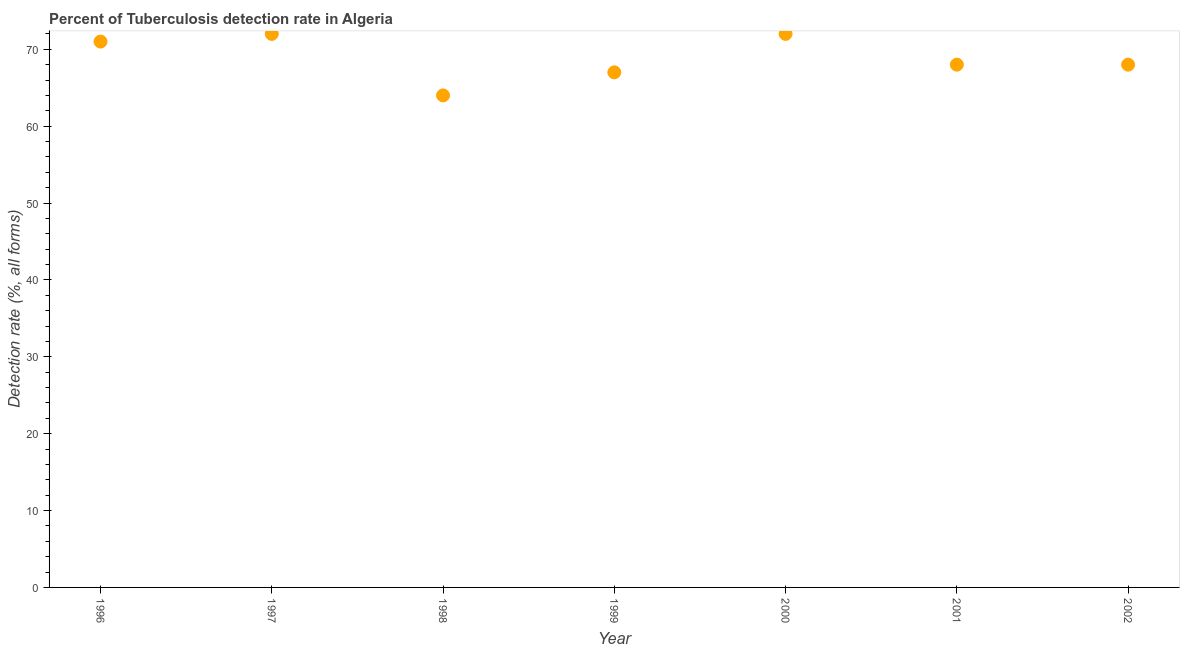What is the detection rate of tuberculosis in 2000?
Your response must be concise. 72. Across all years, what is the maximum detection rate of tuberculosis?
Provide a short and direct response. 72. Across all years, what is the minimum detection rate of tuberculosis?
Ensure brevity in your answer.  64. In which year was the detection rate of tuberculosis maximum?
Your response must be concise. 1997. In which year was the detection rate of tuberculosis minimum?
Provide a succinct answer. 1998. What is the sum of the detection rate of tuberculosis?
Provide a succinct answer. 482. What is the difference between the detection rate of tuberculosis in 1997 and 2001?
Offer a very short reply. 4. What is the average detection rate of tuberculosis per year?
Make the answer very short. 68.86. What is the median detection rate of tuberculosis?
Keep it short and to the point. 68. What is the ratio of the detection rate of tuberculosis in 1996 to that in 1999?
Make the answer very short. 1.06. Is the detection rate of tuberculosis in 1996 less than that in 2002?
Provide a short and direct response. No. Is the difference between the detection rate of tuberculosis in 1996 and 1999 greater than the difference between any two years?
Your answer should be very brief. No. Is the sum of the detection rate of tuberculosis in 1997 and 2001 greater than the maximum detection rate of tuberculosis across all years?
Your answer should be very brief. Yes. What is the difference between the highest and the lowest detection rate of tuberculosis?
Make the answer very short. 8. How many years are there in the graph?
Keep it short and to the point. 7. Are the values on the major ticks of Y-axis written in scientific E-notation?
Make the answer very short. No. Does the graph contain any zero values?
Offer a terse response. No. Does the graph contain grids?
Ensure brevity in your answer.  No. What is the title of the graph?
Provide a succinct answer. Percent of Tuberculosis detection rate in Algeria. What is the label or title of the Y-axis?
Your answer should be very brief. Detection rate (%, all forms). What is the Detection rate (%, all forms) in 1996?
Provide a succinct answer. 71. What is the Detection rate (%, all forms) in 1998?
Provide a short and direct response. 64. What is the Detection rate (%, all forms) in 1999?
Provide a succinct answer. 67. What is the Detection rate (%, all forms) in 2001?
Offer a terse response. 68. What is the Detection rate (%, all forms) in 2002?
Provide a short and direct response. 68. What is the difference between the Detection rate (%, all forms) in 1996 and 1998?
Ensure brevity in your answer.  7. What is the difference between the Detection rate (%, all forms) in 1996 and 1999?
Provide a succinct answer. 4. What is the difference between the Detection rate (%, all forms) in 1996 and 2000?
Make the answer very short. -1. What is the difference between the Detection rate (%, all forms) in 1997 and 2000?
Your response must be concise. 0. What is the difference between the Detection rate (%, all forms) in 1998 and 1999?
Offer a very short reply. -3. What is the difference between the Detection rate (%, all forms) in 1999 and 2000?
Ensure brevity in your answer.  -5. What is the difference between the Detection rate (%, all forms) in 2000 and 2001?
Offer a very short reply. 4. What is the difference between the Detection rate (%, all forms) in 2001 and 2002?
Provide a short and direct response. 0. What is the ratio of the Detection rate (%, all forms) in 1996 to that in 1997?
Provide a succinct answer. 0.99. What is the ratio of the Detection rate (%, all forms) in 1996 to that in 1998?
Offer a very short reply. 1.11. What is the ratio of the Detection rate (%, all forms) in 1996 to that in 1999?
Offer a very short reply. 1.06. What is the ratio of the Detection rate (%, all forms) in 1996 to that in 2000?
Make the answer very short. 0.99. What is the ratio of the Detection rate (%, all forms) in 1996 to that in 2001?
Give a very brief answer. 1.04. What is the ratio of the Detection rate (%, all forms) in 1996 to that in 2002?
Your answer should be very brief. 1.04. What is the ratio of the Detection rate (%, all forms) in 1997 to that in 1999?
Your answer should be compact. 1.07. What is the ratio of the Detection rate (%, all forms) in 1997 to that in 2001?
Give a very brief answer. 1.06. What is the ratio of the Detection rate (%, all forms) in 1997 to that in 2002?
Ensure brevity in your answer.  1.06. What is the ratio of the Detection rate (%, all forms) in 1998 to that in 1999?
Your answer should be very brief. 0.95. What is the ratio of the Detection rate (%, all forms) in 1998 to that in 2000?
Make the answer very short. 0.89. What is the ratio of the Detection rate (%, all forms) in 1998 to that in 2001?
Ensure brevity in your answer.  0.94. What is the ratio of the Detection rate (%, all forms) in 1998 to that in 2002?
Your answer should be very brief. 0.94. What is the ratio of the Detection rate (%, all forms) in 1999 to that in 2001?
Keep it short and to the point. 0.98. What is the ratio of the Detection rate (%, all forms) in 2000 to that in 2001?
Your answer should be very brief. 1.06. What is the ratio of the Detection rate (%, all forms) in 2000 to that in 2002?
Offer a very short reply. 1.06. What is the ratio of the Detection rate (%, all forms) in 2001 to that in 2002?
Provide a short and direct response. 1. 